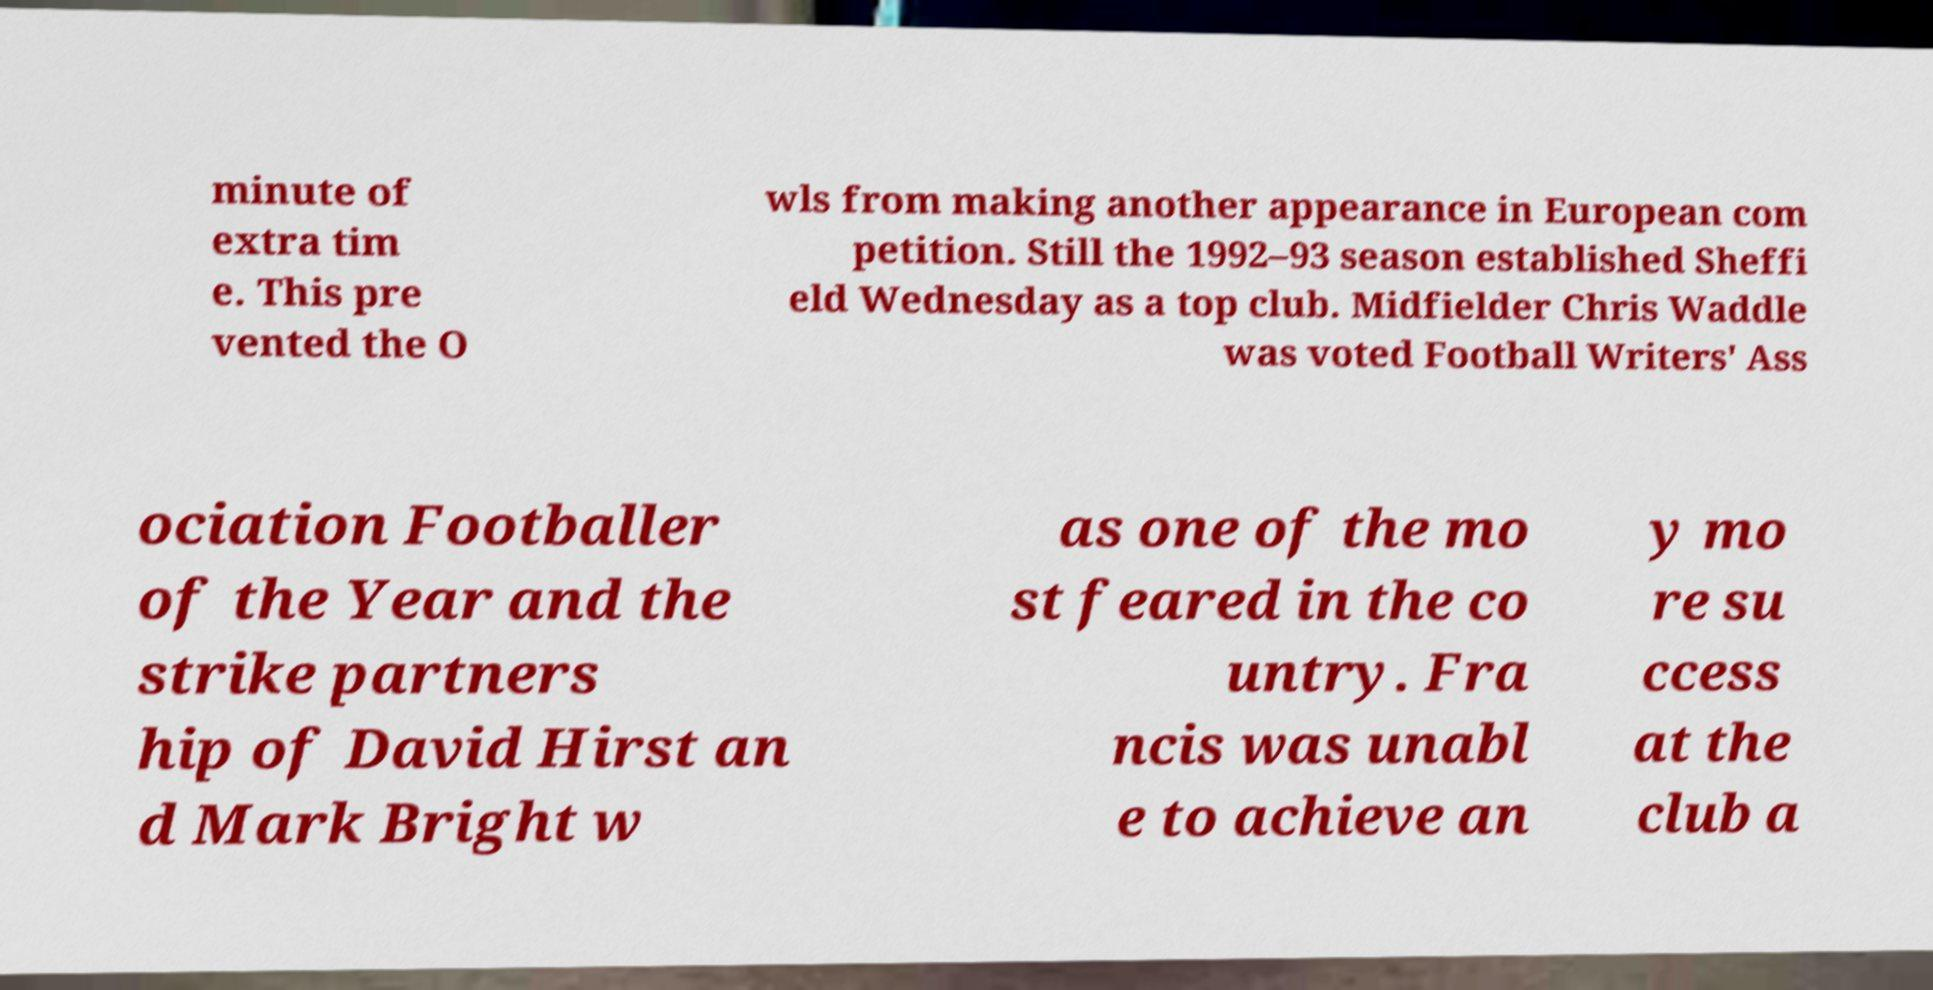There's text embedded in this image that I need extracted. Can you transcribe it verbatim? minute of extra tim e. This pre vented the O wls from making another appearance in European com petition. Still the 1992–93 season established Sheffi eld Wednesday as a top club. Midfielder Chris Waddle was voted Football Writers' Ass ociation Footballer of the Year and the strike partners hip of David Hirst an d Mark Bright w as one of the mo st feared in the co untry. Fra ncis was unabl e to achieve an y mo re su ccess at the club a 